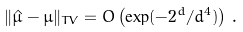Convert formula to latex. <formula><loc_0><loc_0><loc_500><loc_500>\| \hat { \mu } - \mu \| _ { T V } = O \left ( \exp ( - 2 ^ { d } / d ^ { 4 } ) \right ) \, .</formula> 